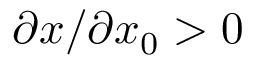Convert formula to latex. <formula><loc_0><loc_0><loc_500><loc_500>\partial x / \partial x _ { 0 } > 0</formula> 